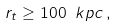<formula> <loc_0><loc_0><loc_500><loc_500>r _ { t } \geq 1 0 0 \ k p c \, ,</formula> 